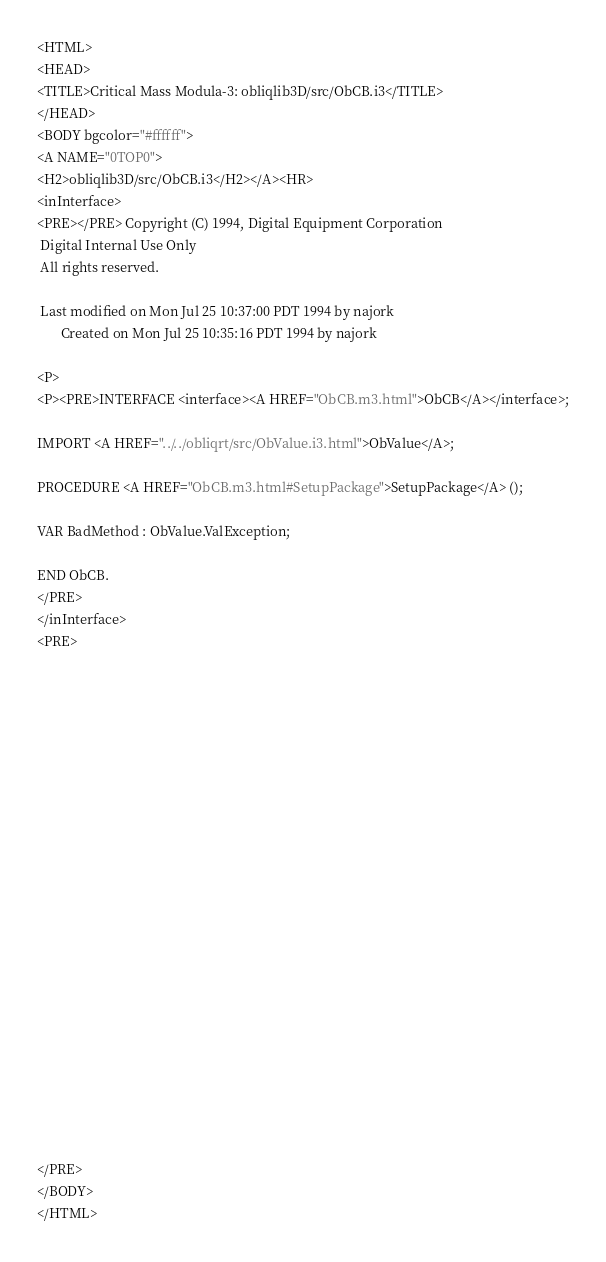<code> <loc_0><loc_0><loc_500><loc_500><_HTML_><HTML>
<HEAD>
<TITLE>Critical Mass Modula-3: obliqlib3D/src/ObCB.i3</TITLE>
</HEAD>
<BODY bgcolor="#ffffff">
<A NAME="0TOP0">
<H2>obliqlib3D/src/ObCB.i3</H2></A><HR>
<inInterface>
<PRE></PRE> Copyright (C) 1994, Digital Equipment Corporation                         
 Digital Internal Use Only                                                 
 All rights reserved.                                                      
                                                                           
 Last modified on Mon Jul 25 10:37:00 PDT 1994 by najork                   
       Created on Mon Jul 25 10:35:16 PDT 1994 by najork                   

<P>
<P><PRE>INTERFACE <interface><A HREF="ObCB.m3.html">ObCB</A></interface>;

IMPORT <A HREF="../../obliqrt/src/ObValue.i3.html">ObValue</A>;

PROCEDURE <A HREF="ObCB.m3.html#SetupPackage">SetupPackage</A> ();

VAR BadMethod : ObValue.ValException;

END ObCB.
</PRE>
</inInterface>
<PRE>























</PRE>
</BODY>
</HTML>
</code> 